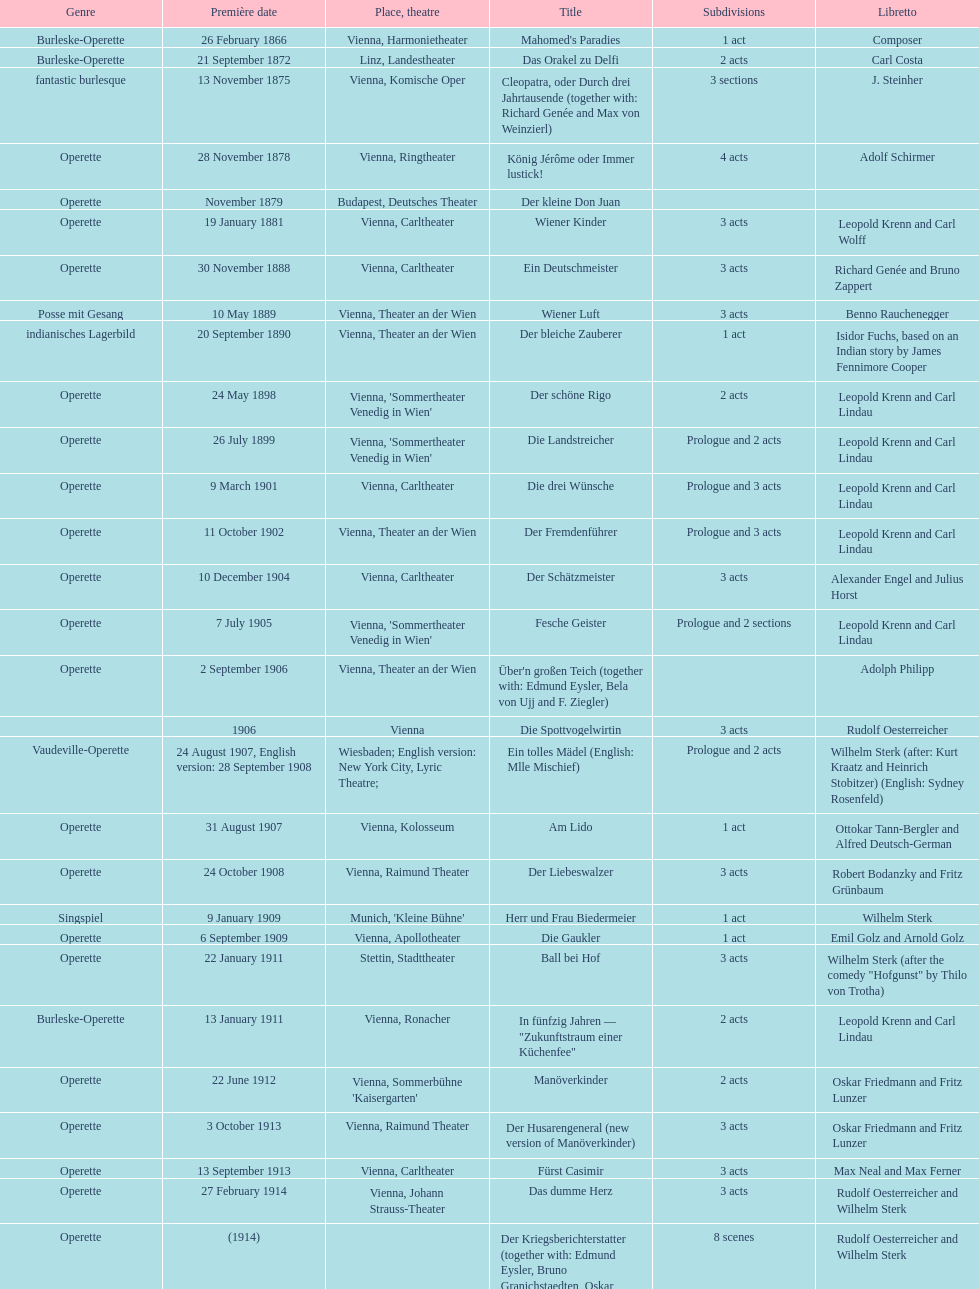What are the number of titles that premiered in the month of september? 4. 